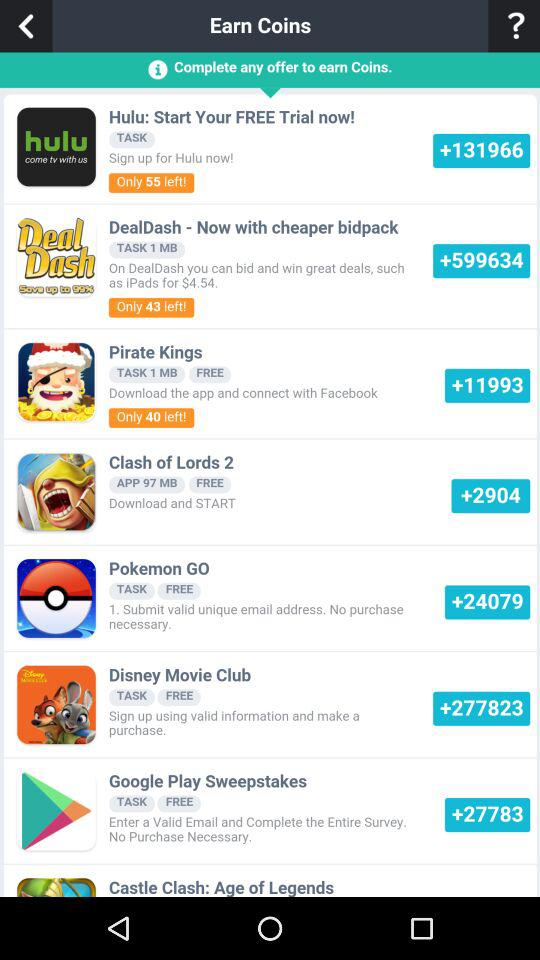How many coins can we earn by downloading and starting "Clash of Lords 2"? You can earn more than 2904 coins by downloading and starting "Clash of Lords 2". 